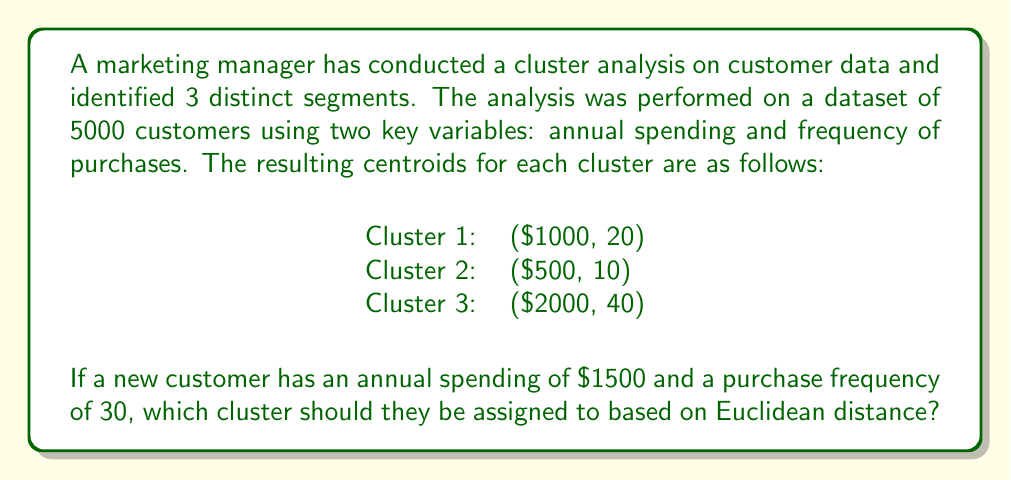Help me with this question. To determine which cluster the new customer should be assigned to, we need to calculate the Euclidean distance between the new customer's data point and each cluster centroid. The cluster with the smallest distance is the one the new customer should be assigned to.

The Euclidean distance formula in two dimensions is:

$$d = \sqrt{(x_2 - x_1)^2 + (y_2 - y_1)^2}$$

Where $(x_1, y_1)$ is the centroid and $(x_2, y_2)$ is the new customer's data point.

Let's calculate the distance for each cluster:

1. For Cluster 1:
   $d_1 = \sqrt{(1500 - 1000)^2 + (30 - 20)^2}$
   $d_1 = \sqrt{500^2 + 10^2}$
   $d_1 = \sqrt{250000 + 100}$
   $d_1 = \sqrt{250100} \approx 500.10$

2. For Cluster 2:
   $d_2 = \sqrt{(1500 - 500)^2 + (30 - 10)^2}$
   $d_2 = \sqrt{1000^2 + 20^2}$
   $d_2 = \sqrt{1000000 + 400}$
   $d_2 = \sqrt{1000400} \approx 1000.20$

3. For Cluster 3:
   $d_3 = \sqrt{(1500 - 2000)^2 + (30 - 40)^2}$
   $d_3 = \sqrt{(-500)^2 + (-10)^2}$
   $d_3 = \sqrt{250000 + 100}$
   $d_3 = \sqrt{250100} \approx 500.10$

The smallest distance is shared by Cluster 1 and Cluster 3. In cases of a tie, we can choose either cluster or implement a tie-breaking rule. For this example, we'll choose the cluster that appears first in the list.
Answer: Cluster 1 